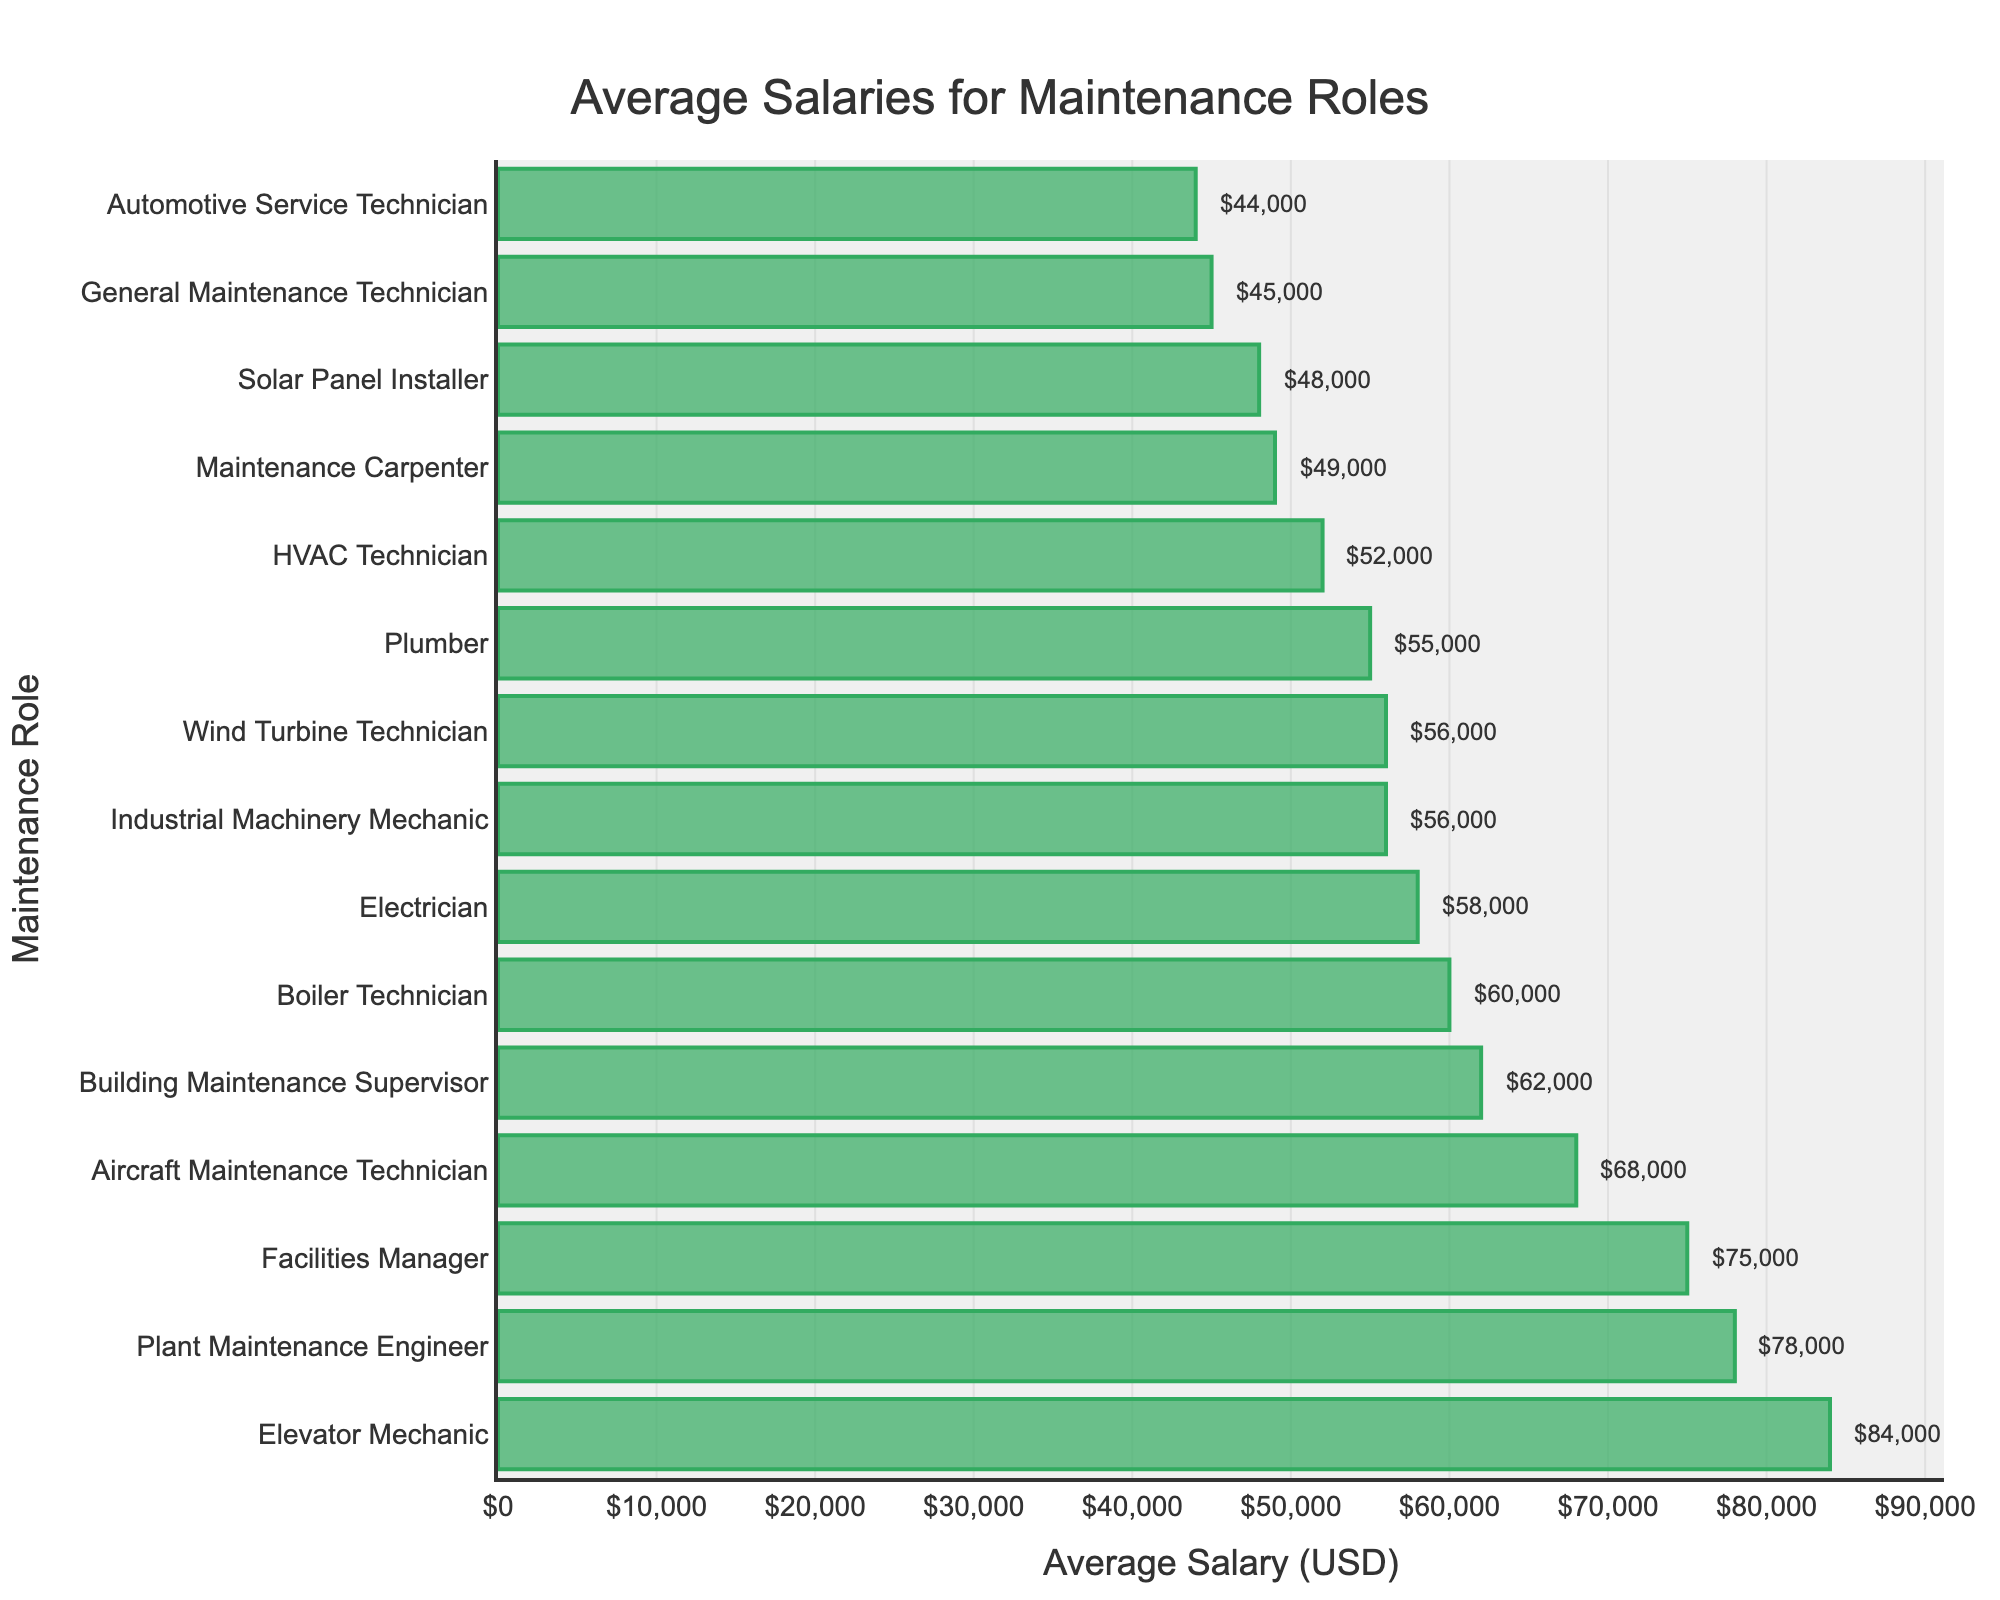Which role has the highest average salary? The bar representing the Elevator Mechanic has the greatest length, which indicates it is the highest salary.
Answer: Elevator Mechanic What is the average salary of the Facilities Manager? By reading the label at the end of the Facilities Manager's bar, we see the average salary.
Answer: $75,000 Which role has a higher average salary: Plumber or Electrician? By comparing the lengths of the bars and the labels, we see the Electrician's bar is longer than the Plumber's.
Answer: Electrician What is the total combined salary of the General Maintenance Technician, HVAC Technician, and Electrician? The values are $45,000, $52,000, and $58,000 respectively. Summing them up: $45,000 + $52,000 + $58,000 = $155,000.
Answer: $155,000 How much more does an Industrial Machinery Mechanic make compared to an Automotive Service Technician? The Industrial Machinery Mechanic makes $56,000 while the Automotive Service Technician makes $44,000. The difference is $56,000 - $44,000 = $12,000.
Answer: $12,000 What is the smallest average salary on the chart? The Automotive Service Technician has the shortest bar which means it has the smallest salary.
Answer: $44,000 What roles have an average salary higher than $60,000? By checking the bars that extend beyond the $60,000 mark, those roles are Facilities Manager, Building Maintenance Supervisor, Aircraft Maintenance Technician, Elevator Mechanic, Boiler Technician, and Plant Maintenance Engineer.
Answer: Facilities Manager, Building Maintenance Supervisor, Aircraft Maintenance Technician, Elevator Mechanic, Boiler Technician, Plant Maintenance Engineer What is the difference in average salary between the highest-paying and lowest-paying roles? The highest salary is $84,000 for Elevator Mechanic and the lowest is $44,000 for Automotive Service Technician. The difference is $84,000 - $44,000 = $40,000.
Answer: $40,000 What is the average salary of all listed maintenance roles? Summing up all average salaries and dividing by the number of roles: ($45,000 + $52,000 + $58,000 + $55,000 + $56,000 + $75,000 + $62,000 + $44,000 + $68,000 + $56,000 + $48,000 + $84,000 + $60,000 + $49,000 + $78,000) / 15 = $59,800.
Answer: $59,800 